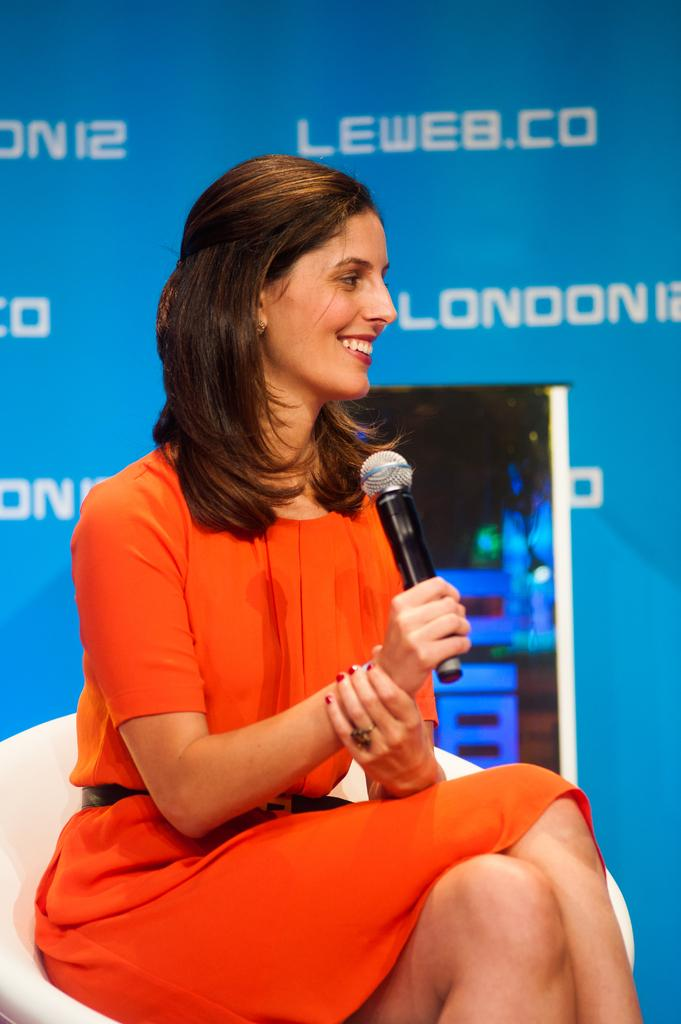Who is the main subject in the image? There is a woman in the image. What is the woman wearing? The woman is wearing an orange dress. What is the woman doing in the image? The woman is sitting on a chair, speaking, and laughing. What can be seen in the background of the image? There is a blue color logo in the background of the image. What type of paint is being used by the woman in the image? There is no indication in the image that the woman is using paint, so it cannot be determined from the picture. 